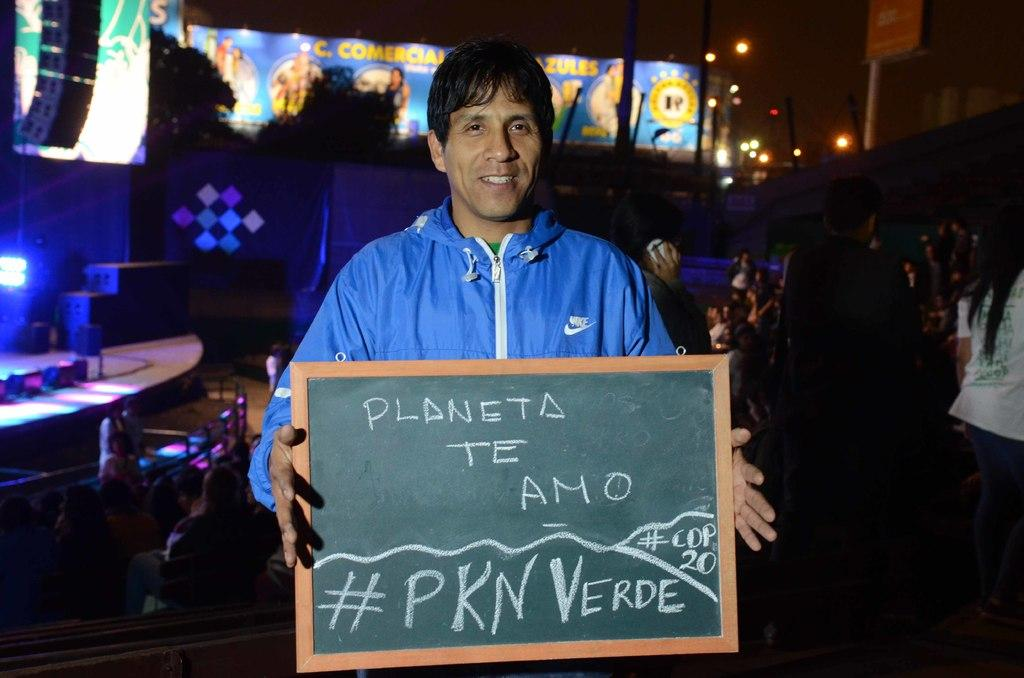Who is the main subject in the picture? There is a man in the middle of the picture. What is the man holding in his hands? The man is holding a small black board in his hands. What is the man's facial expression? The man is smiling. Can you describe the people visible in the background of the picture? There are people visible in the background of the picture, but their specific details are not mentioned in the facts. What type of operation is the man performing on the flesh in the image? There is no operation or flesh present in the image; it features a man holding a small black board and smiling. 